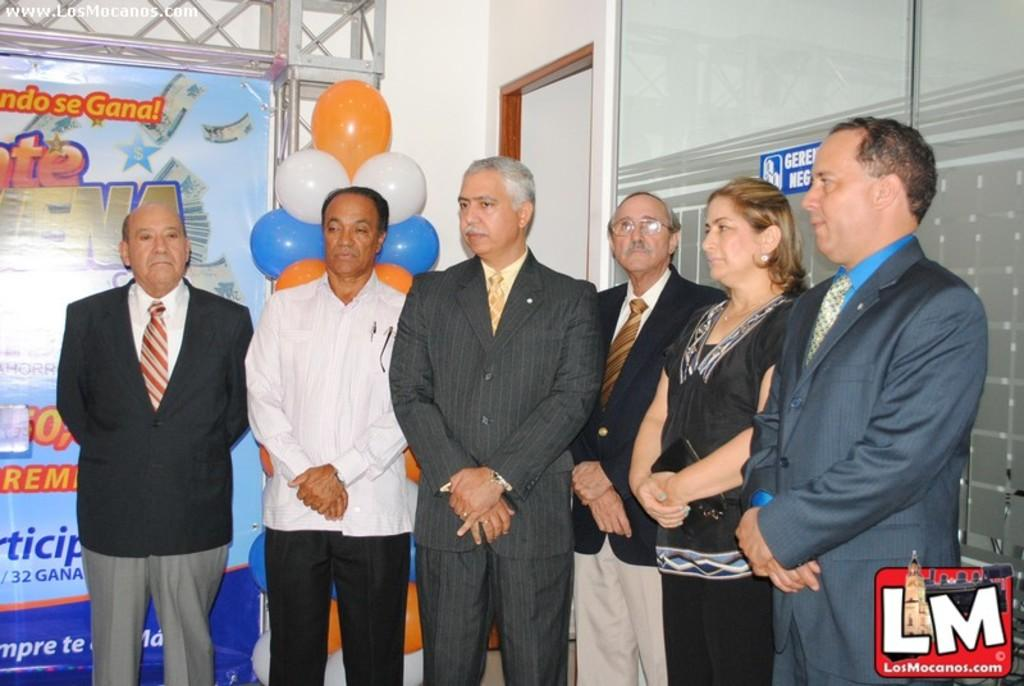What is happening in the image? There are persons standing in the image. What are the persons wearing? The persons are wearing clothes. What can be seen in the middle of the image? There are balloons in the middle of the image. What is on the left side of the image? There is a banner on the left side of the image. What action is the surprise taking in the image? There is no surprise present in the image; it features persons standing and balloons. What idea is being expressed on the banner in the image? The image does not provide enough information to determine the idea being expressed on the banner, as the text is not legible. 